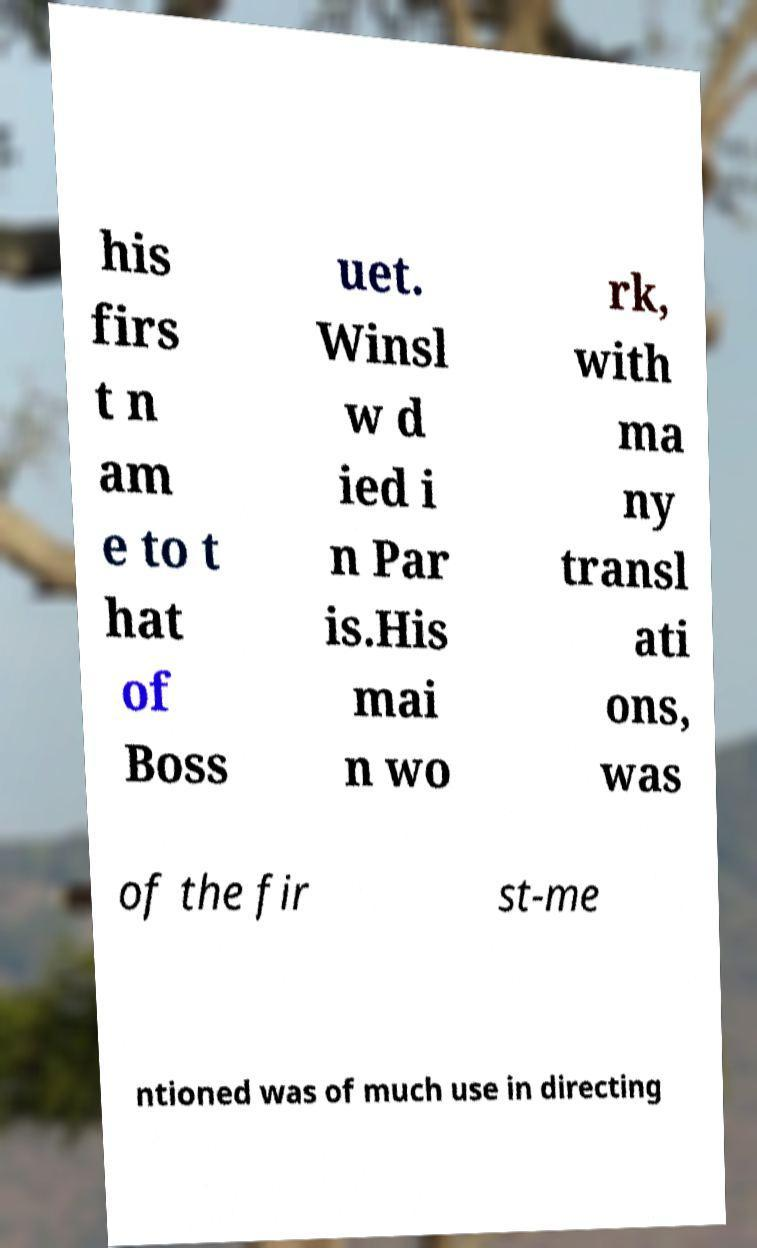There's text embedded in this image that I need extracted. Can you transcribe it verbatim? his firs t n am e to t hat of Boss uet. Winsl w d ied i n Par is.His mai n wo rk, with ma ny transl ati ons, was of the fir st-me ntioned was of much use in directing 